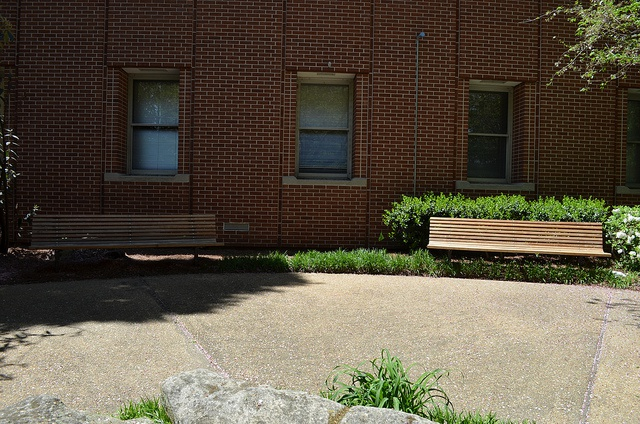Describe the objects in this image and their specific colors. I can see bench in black and gray tones and bench in black and tan tones in this image. 